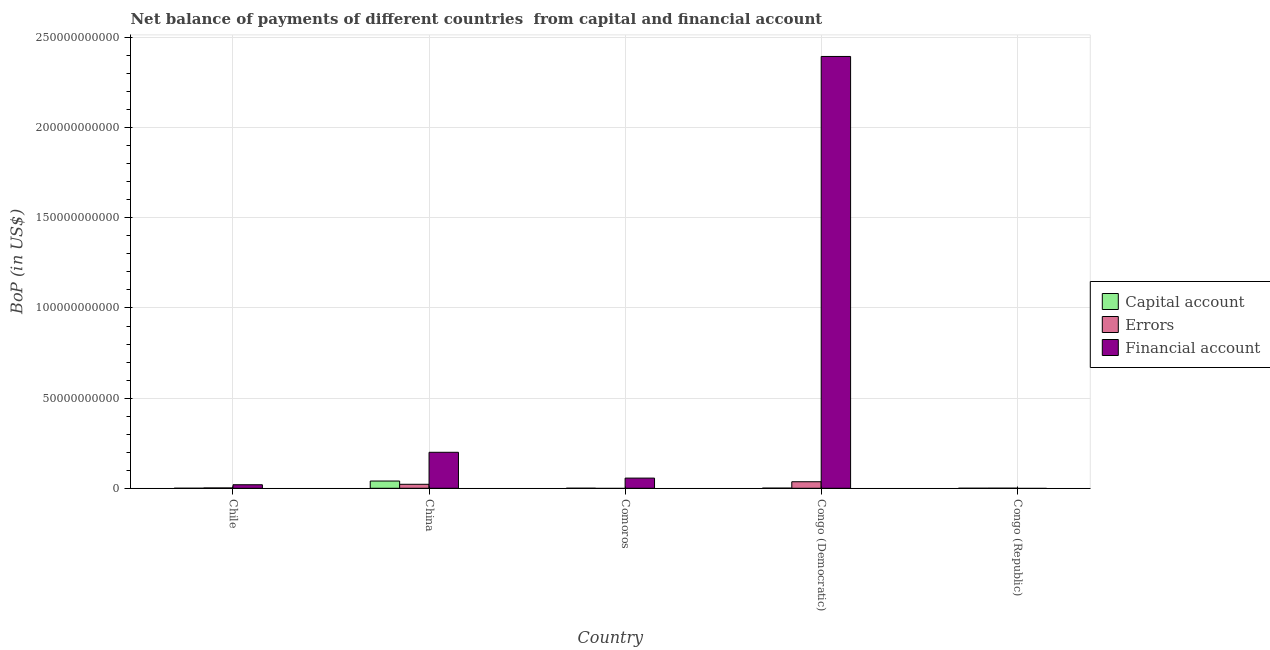How many different coloured bars are there?
Keep it short and to the point. 3. How many groups of bars are there?
Provide a short and direct response. 5. Are the number of bars per tick equal to the number of legend labels?
Provide a short and direct response. No. What is the label of the 5th group of bars from the left?
Your response must be concise. Congo (Republic). In how many cases, is the number of bars for a given country not equal to the number of legend labels?
Make the answer very short. 2. What is the amount of net capital account in Chile?
Offer a terse response. 1.33e+07. Across all countries, what is the maximum amount of net capital account?
Keep it short and to the point. 4.02e+09. Across all countries, what is the minimum amount of financial account?
Provide a short and direct response. 0. In which country was the amount of errors maximum?
Offer a very short reply. Congo (Democratic). What is the total amount of financial account in the graph?
Your answer should be very brief. 2.67e+11. What is the difference between the amount of net capital account in Comoros and that in Congo (Democratic)?
Keep it short and to the point. -6.33e+07. What is the difference between the amount of net capital account in Comoros and the amount of errors in Congo (Democratic)?
Provide a short and direct response. -3.61e+09. What is the average amount of errors per country?
Keep it short and to the point. 1.21e+09. What is the difference between the amount of financial account and amount of errors in Congo (Democratic)?
Keep it short and to the point. 2.36e+11. What is the ratio of the amount of net capital account in Comoros to that in Congo (Democratic)?
Provide a short and direct response. 0.23. Is the amount of financial account in Comoros less than that in Congo (Democratic)?
Offer a terse response. Yes. What is the difference between the highest and the second highest amount of errors?
Make the answer very short. 1.42e+09. What is the difference between the highest and the lowest amount of errors?
Your answer should be compact. 3.63e+09. In how many countries, is the amount of net capital account greater than the average amount of net capital account taken over all countries?
Give a very brief answer. 1. Is the sum of the amount of financial account in Comoros and Congo (Democratic) greater than the maximum amount of net capital account across all countries?
Provide a succinct answer. Yes. How many bars are there?
Provide a short and direct response. 13. Are all the bars in the graph horizontal?
Make the answer very short. No. How many countries are there in the graph?
Make the answer very short. 5. How many legend labels are there?
Provide a succinct answer. 3. What is the title of the graph?
Your answer should be compact. Net balance of payments of different countries  from capital and financial account. Does "Labor Market" appear as one of the legend labels in the graph?
Provide a succinct answer. No. What is the label or title of the X-axis?
Make the answer very short. Country. What is the label or title of the Y-axis?
Offer a very short reply. BoP (in US$). What is the BoP (in US$) in Capital account in Chile?
Your answer should be compact. 1.33e+07. What is the BoP (in US$) of Errors in Chile?
Your answer should be compact. 1.83e+08. What is the BoP (in US$) in Financial account in Chile?
Offer a terse response. 1.96e+09. What is the BoP (in US$) in Capital account in China?
Give a very brief answer. 4.02e+09. What is the BoP (in US$) in Errors in China?
Your response must be concise. 2.21e+09. What is the BoP (in US$) in Financial account in China?
Keep it short and to the point. 2.00e+1. What is the BoP (in US$) in Capital account in Comoros?
Ensure brevity in your answer.  1.85e+07. What is the BoP (in US$) in Errors in Comoros?
Your answer should be very brief. 0. What is the BoP (in US$) in Financial account in Comoros?
Your answer should be very brief. 5.64e+09. What is the BoP (in US$) of Capital account in Congo (Democratic)?
Give a very brief answer. 8.17e+07. What is the BoP (in US$) of Errors in Congo (Democratic)?
Keep it short and to the point. 3.63e+09. What is the BoP (in US$) in Financial account in Congo (Democratic)?
Your response must be concise. 2.39e+11. What is the BoP (in US$) in Capital account in Congo (Republic)?
Your response must be concise. 9.56e+06. What is the BoP (in US$) in Errors in Congo (Republic)?
Your answer should be very brief. 3.87e+07. Across all countries, what is the maximum BoP (in US$) in Capital account?
Keep it short and to the point. 4.02e+09. Across all countries, what is the maximum BoP (in US$) in Errors?
Offer a terse response. 3.63e+09. Across all countries, what is the maximum BoP (in US$) of Financial account?
Give a very brief answer. 2.39e+11. Across all countries, what is the minimum BoP (in US$) in Capital account?
Your answer should be compact. 9.56e+06. Across all countries, what is the minimum BoP (in US$) of Errors?
Your answer should be compact. 0. What is the total BoP (in US$) in Capital account in the graph?
Provide a succinct answer. 4.14e+09. What is the total BoP (in US$) of Errors in the graph?
Offer a very short reply. 6.06e+09. What is the total BoP (in US$) of Financial account in the graph?
Provide a succinct answer. 2.67e+11. What is the difference between the BoP (in US$) of Capital account in Chile and that in China?
Ensure brevity in your answer.  -4.01e+09. What is the difference between the BoP (in US$) in Errors in Chile and that in China?
Your response must be concise. -2.03e+09. What is the difference between the BoP (in US$) of Financial account in Chile and that in China?
Provide a short and direct response. -1.80e+1. What is the difference between the BoP (in US$) of Capital account in Chile and that in Comoros?
Make the answer very short. -5.16e+06. What is the difference between the BoP (in US$) of Financial account in Chile and that in Comoros?
Give a very brief answer. -3.68e+09. What is the difference between the BoP (in US$) in Capital account in Chile and that in Congo (Democratic)?
Your answer should be compact. -6.84e+07. What is the difference between the BoP (in US$) of Errors in Chile and that in Congo (Democratic)?
Make the answer very short. -3.45e+09. What is the difference between the BoP (in US$) of Financial account in Chile and that in Congo (Democratic)?
Your answer should be compact. -2.38e+11. What is the difference between the BoP (in US$) in Capital account in Chile and that in Congo (Republic)?
Provide a short and direct response. 3.74e+06. What is the difference between the BoP (in US$) in Errors in Chile and that in Congo (Republic)?
Offer a very short reply. 1.44e+08. What is the difference between the BoP (in US$) of Capital account in China and that in Comoros?
Offer a very short reply. 4.00e+09. What is the difference between the BoP (in US$) in Financial account in China and that in Comoros?
Your answer should be compact. 1.43e+1. What is the difference between the BoP (in US$) of Capital account in China and that in Congo (Democratic)?
Offer a terse response. 3.94e+09. What is the difference between the BoP (in US$) of Errors in China and that in Congo (Democratic)?
Keep it short and to the point. -1.42e+09. What is the difference between the BoP (in US$) of Financial account in China and that in Congo (Democratic)?
Provide a succinct answer. -2.20e+11. What is the difference between the BoP (in US$) of Capital account in China and that in Congo (Republic)?
Your answer should be compact. 4.01e+09. What is the difference between the BoP (in US$) in Errors in China and that in Congo (Republic)?
Provide a succinct answer. 2.17e+09. What is the difference between the BoP (in US$) of Capital account in Comoros and that in Congo (Democratic)?
Provide a short and direct response. -6.33e+07. What is the difference between the BoP (in US$) of Financial account in Comoros and that in Congo (Democratic)?
Provide a short and direct response. -2.34e+11. What is the difference between the BoP (in US$) in Capital account in Comoros and that in Congo (Republic)?
Provide a short and direct response. 8.90e+06. What is the difference between the BoP (in US$) of Capital account in Congo (Democratic) and that in Congo (Republic)?
Ensure brevity in your answer.  7.22e+07. What is the difference between the BoP (in US$) of Errors in Congo (Democratic) and that in Congo (Republic)?
Offer a terse response. 3.59e+09. What is the difference between the BoP (in US$) of Capital account in Chile and the BoP (in US$) of Errors in China?
Ensure brevity in your answer.  -2.20e+09. What is the difference between the BoP (in US$) in Capital account in Chile and the BoP (in US$) in Financial account in China?
Give a very brief answer. -1.99e+1. What is the difference between the BoP (in US$) of Errors in Chile and the BoP (in US$) of Financial account in China?
Give a very brief answer. -1.98e+1. What is the difference between the BoP (in US$) of Capital account in Chile and the BoP (in US$) of Financial account in Comoros?
Ensure brevity in your answer.  -5.63e+09. What is the difference between the BoP (in US$) of Errors in Chile and the BoP (in US$) of Financial account in Comoros?
Your answer should be compact. -5.46e+09. What is the difference between the BoP (in US$) of Capital account in Chile and the BoP (in US$) of Errors in Congo (Democratic)?
Provide a succinct answer. -3.61e+09. What is the difference between the BoP (in US$) in Capital account in Chile and the BoP (in US$) in Financial account in Congo (Democratic)?
Your response must be concise. -2.39e+11. What is the difference between the BoP (in US$) in Errors in Chile and the BoP (in US$) in Financial account in Congo (Democratic)?
Your answer should be compact. -2.39e+11. What is the difference between the BoP (in US$) in Capital account in Chile and the BoP (in US$) in Errors in Congo (Republic)?
Your response must be concise. -2.54e+07. What is the difference between the BoP (in US$) in Capital account in China and the BoP (in US$) in Financial account in Comoros?
Provide a short and direct response. -1.62e+09. What is the difference between the BoP (in US$) of Errors in China and the BoP (in US$) of Financial account in Comoros?
Keep it short and to the point. -3.43e+09. What is the difference between the BoP (in US$) of Capital account in China and the BoP (in US$) of Errors in Congo (Democratic)?
Offer a terse response. 3.92e+08. What is the difference between the BoP (in US$) of Capital account in China and the BoP (in US$) of Financial account in Congo (Democratic)?
Give a very brief answer. -2.35e+11. What is the difference between the BoP (in US$) in Errors in China and the BoP (in US$) in Financial account in Congo (Democratic)?
Your answer should be compact. -2.37e+11. What is the difference between the BoP (in US$) of Capital account in China and the BoP (in US$) of Errors in Congo (Republic)?
Give a very brief answer. 3.98e+09. What is the difference between the BoP (in US$) in Capital account in Comoros and the BoP (in US$) in Errors in Congo (Democratic)?
Offer a terse response. -3.61e+09. What is the difference between the BoP (in US$) in Capital account in Comoros and the BoP (in US$) in Financial account in Congo (Democratic)?
Your response must be concise. -2.39e+11. What is the difference between the BoP (in US$) in Capital account in Comoros and the BoP (in US$) in Errors in Congo (Republic)?
Your answer should be compact. -2.02e+07. What is the difference between the BoP (in US$) of Capital account in Congo (Democratic) and the BoP (in US$) of Errors in Congo (Republic)?
Your answer should be very brief. 4.31e+07. What is the average BoP (in US$) of Capital account per country?
Your response must be concise. 8.29e+08. What is the average BoP (in US$) of Errors per country?
Make the answer very short. 1.21e+09. What is the average BoP (in US$) in Financial account per country?
Provide a succinct answer. 5.34e+1. What is the difference between the BoP (in US$) in Capital account and BoP (in US$) in Errors in Chile?
Offer a very short reply. -1.70e+08. What is the difference between the BoP (in US$) in Capital account and BoP (in US$) in Financial account in Chile?
Your answer should be very brief. -1.95e+09. What is the difference between the BoP (in US$) in Errors and BoP (in US$) in Financial account in Chile?
Ensure brevity in your answer.  -1.78e+09. What is the difference between the BoP (in US$) of Capital account and BoP (in US$) of Errors in China?
Ensure brevity in your answer.  1.81e+09. What is the difference between the BoP (in US$) in Capital account and BoP (in US$) in Financial account in China?
Your answer should be compact. -1.59e+1. What is the difference between the BoP (in US$) in Errors and BoP (in US$) in Financial account in China?
Offer a terse response. -1.77e+1. What is the difference between the BoP (in US$) in Capital account and BoP (in US$) in Financial account in Comoros?
Ensure brevity in your answer.  -5.62e+09. What is the difference between the BoP (in US$) in Capital account and BoP (in US$) in Errors in Congo (Democratic)?
Your response must be concise. -3.55e+09. What is the difference between the BoP (in US$) in Capital account and BoP (in US$) in Financial account in Congo (Democratic)?
Give a very brief answer. -2.39e+11. What is the difference between the BoP (in US$) in Errors and BoP (in US$) in Financial account in Congo (Democratic)?
Give a very brief answer. -2.36e+11. What is the difference between the BoP (in US$) in Capital account and BoP (in US$) in Errors in Congo (Republic)?
Your response must be concise. -2.91e+07. What is the ratio of the BoP (in US$) in Capital account in Chile to that in China?
Offer a very short reply. 0. What is the ratio of the BoP (in US$) of Errors in Chile to that in China?
Provide a short and direct response. 0.08. What is the ratio of the BoP (in US$) of Financial account in Chile to that in China?
Your answer should be very brief. 0.1. What is the ratio of the BoP (in US$) in Capital account in Chile to that in Comoros?
Keep it short and to the point. 0.72. What is the ratio of the BoP (in US$) in Financial account in Chile to that in Comoros?
Keep it short and to the point. 0.35. What is the ratio of the BoP (in US$) of Capital account in Chile to that in Congo (Democratic)?
Your answer should be compact. 0.16. What is the ratio of the BoP (in US$) of Errors in Chile to that in Congo (Democratic)?
Give a very brief answer. 0.05. What is the ratio of the BoP (in US$) in Financial account in Chile to that in Congo (Democratic)?
Ensure brevity in your answer.  0.01. What is the ratio of the BoP (in US$) of Capital account in Chile to that in Congo (Republic)?
Offer a very short reply. 1.39. What is the ratio of the BoP (in US$) in Errors in Chile to that in Congo (Republic)?
Provide a short and direct response. 4.73. What is the ratio of the BoP (in US$) of Capital account in China to that in Comoros?
Your answer should be very brief. 217.76. What is the ratio of the BoP (in US$) of Financial account in China to that in Comoros?
Give a very brief answer. 3.54. What is the ratio of the BoP (in US$) in Capital account in China to that in Congo (Democratic)?
Your answer should be compact. 49.19. What is the ratio of the BoP (in US$) in Errors in China to that in Congo (Democratic)?
Your response must be concise. 0.61. What is the ratio of the BoP (in US$) in Financial account in China to that in Congo (Democratic)?
Provide a short and direct response. 0.08. What is the ratio of the BoP (in US$) in Capital account in China to that in Congo (Republic)?
Provide a short and direct response. 420.42. What is the ratio of the BoP (in US$) of Errors in China to that in Congo (Republic)?
Provide a succinct answer. 57.22. What is the ratio of the BoP (in US$) in Capital account in Comoros to that in Congo (Democratic)?
Offer a terse response. 0.23. What is the ratio of the BoP (in US$) in Financial account in Comoros to that in Congo (Democratic)?
Your answer should be compact. 0.02. What is the ratio of the BoP (in US$) of Capital account in Comoros to that in Congo (Republic)?
Provide a short and direct response. 1.93. What is the ratio of the BoP (in US$) of Capital account in Congo (Democratic) to that in Congo (Republic)?
Offer a very short reply. 8.55. What is the ratio of the BoP (in US$) of Errors in Congo (Democratic) to that in Congo (Republic)?
Provide a succinct answer. 93.86. What is the difference between the highest and the second highest BoP (in US$) in Capital account?
Make the answer very short. 3.94e+09. What is the difference between the highest and the second highest BoP (in US$) in Errors?
Your answer should be very brief. 1.42e+09. What is the difference between the highest and the second highest BoP (in US$) in Financial account?
Your answer should be very brief. 2.20e+11. What is the difference between the highest and the lowest BoP (in US$) in Capital account?
Provide a short and direct response. 4.01e+09. What is the difference between the highest and the lowest BoP (in US$) of Errors?
Provide a succinct answer. 3.63e+09. What is the difference between the highest and the lowest BoP (in US$) in Financial account?
Give a very brief answer. 2.39e+11. 